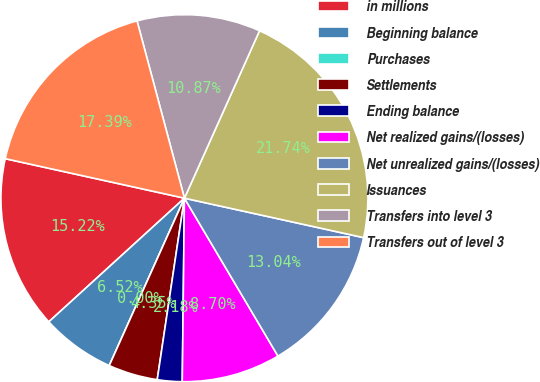Convert chart to OTSL. <chart><loc_0><loc_0><loc_500><loc_500><pie_chart><fcel>in millions<fcel>Beginning balance<fcel>Purchases<fcel>Settlements<fcel>Ending balance<fcel>Net realized gains/(losses)<fcel>Net unrealized gains/(losses)<fcel>Issuances<fcel>Transfers into level 3<fcel>Transfers out of level 3<nl><fcel>15.22%<fcel>6.52%<fcel>0.0%<fcel>4.35%<fcel>2.18%<fcel>8.7%<fcel>13.04%<fcel>21.74%<fcel>10.87%<fcel>17.39%<nl></chart> 